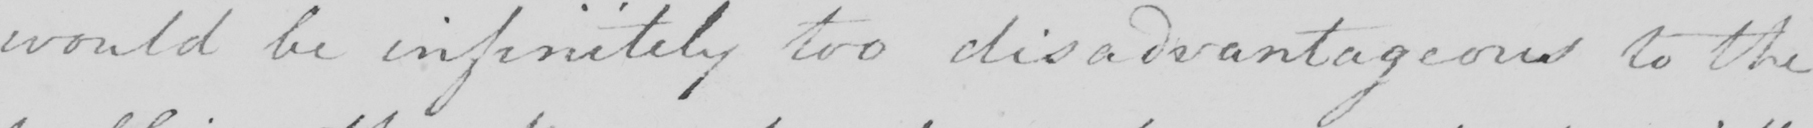Please provide the text content of this handwritten line. would be infinitely too disadvantageous to the 